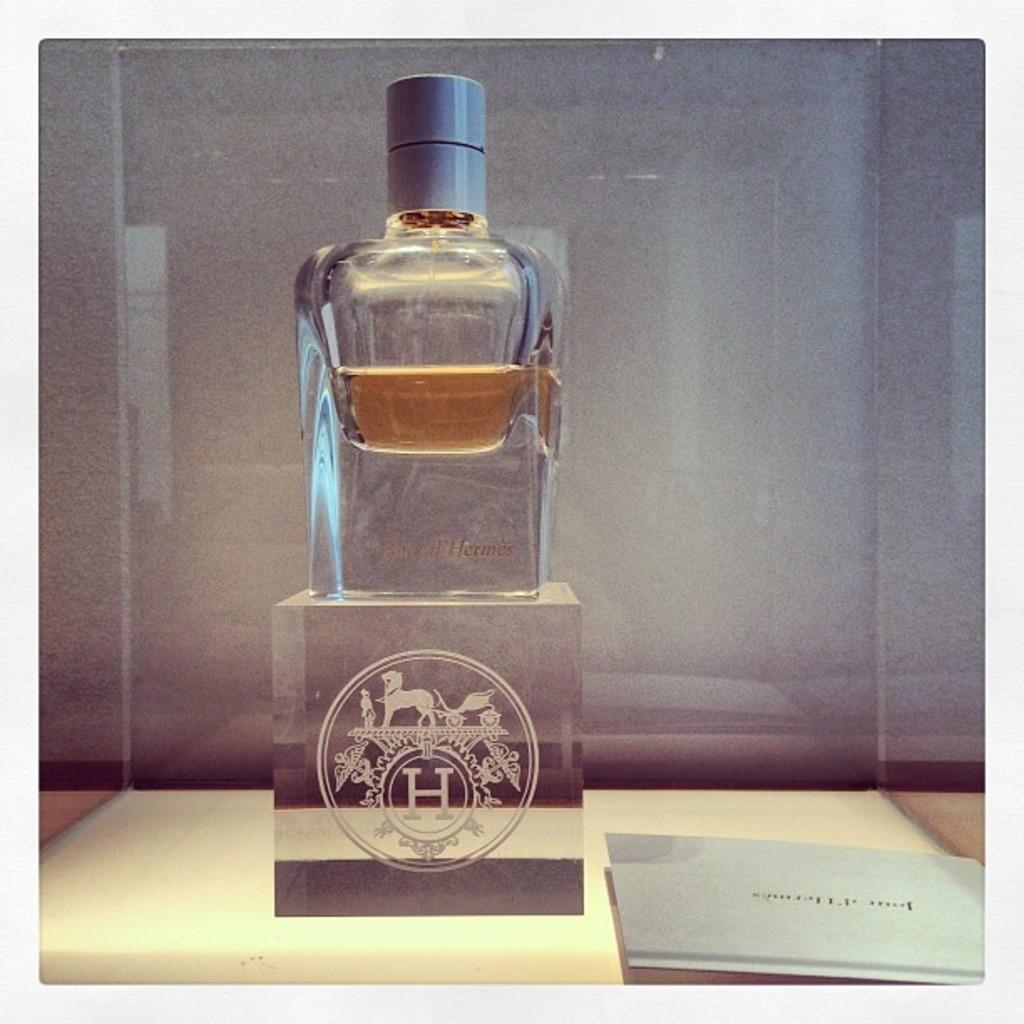Please provide a concise description of this image. A bottle is kept on a stand with a logo is kept on a table. There is a paper on the table. 